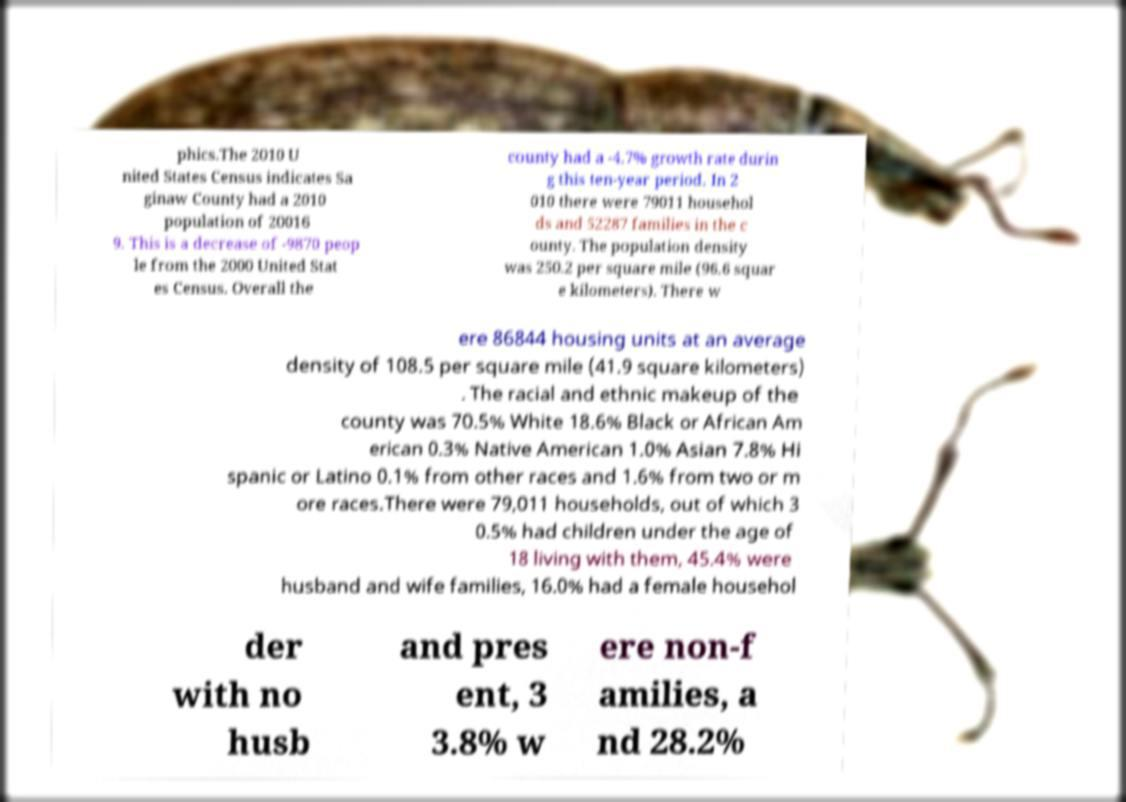Please identify and transcribe the text found in this image. phics.The 2010 U nited States Census indicates Sa ginaw County had a 2010 population of 20016 9. This is a decrease of -9870 peop le from the 2000 United Stat es Census. Overall the county had a -4.7% growth rate durin g this ten-year period. In 2 010 there were 79011 househol ds and 52287 families in the c ounty. The population density was 250.2 per square mile (96.6 squar e kilometers). There w ere 86844 housing units at an average density of 108.5 per square mile (41.9 square kilometers) . The racial and ethnic makeup of the county was 70.5% White 18.6% Black or African Am erican 0.3% Native American 1.0% Asian 7.8% Hi spanic or Latino 0.1% from other races and 1.6% from two or m ore races.There were 79,011 households, out of which 3 0.5% had children under the age of 18 living with them, 45.4% were husband and wife families, 16.0% had a female househol der with no husb and pres ent, 3 3.8% w ere non-f amilies, a nd 28.2% 